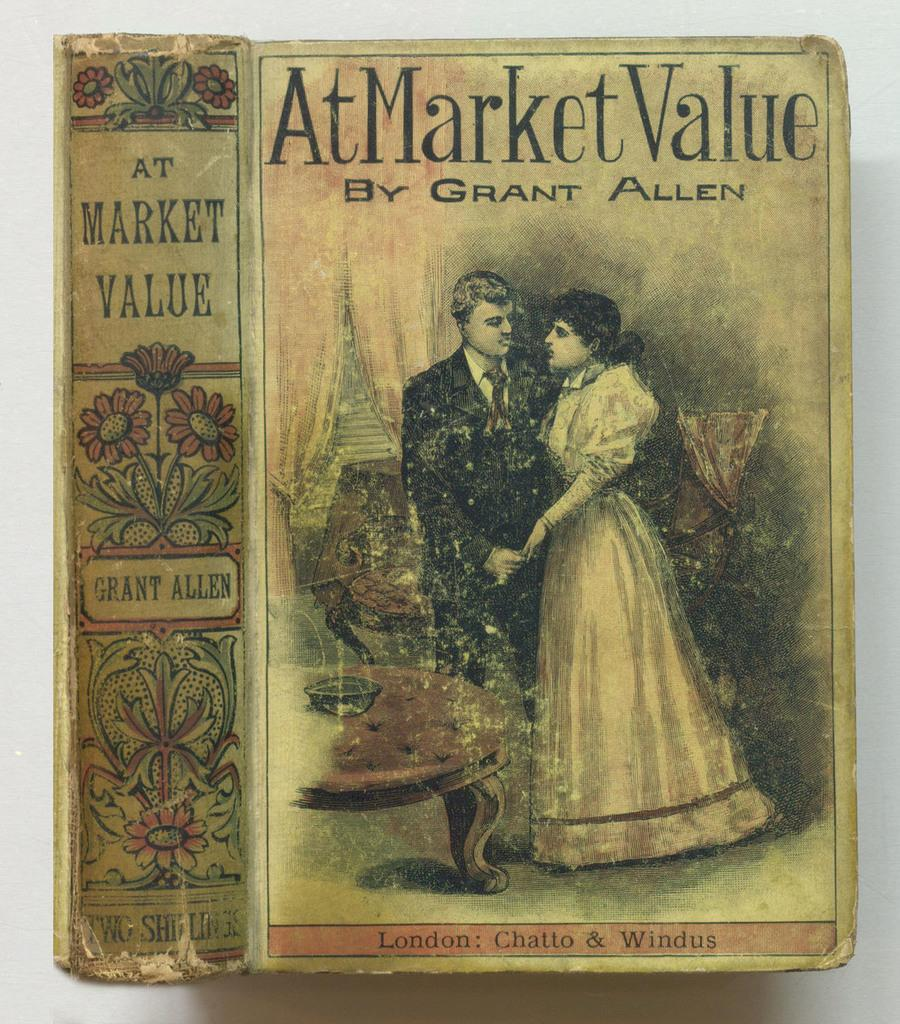<image>
Create a compact narrative representing the image presented. The book AT MARKET VALUE was written by Grant Allen. 